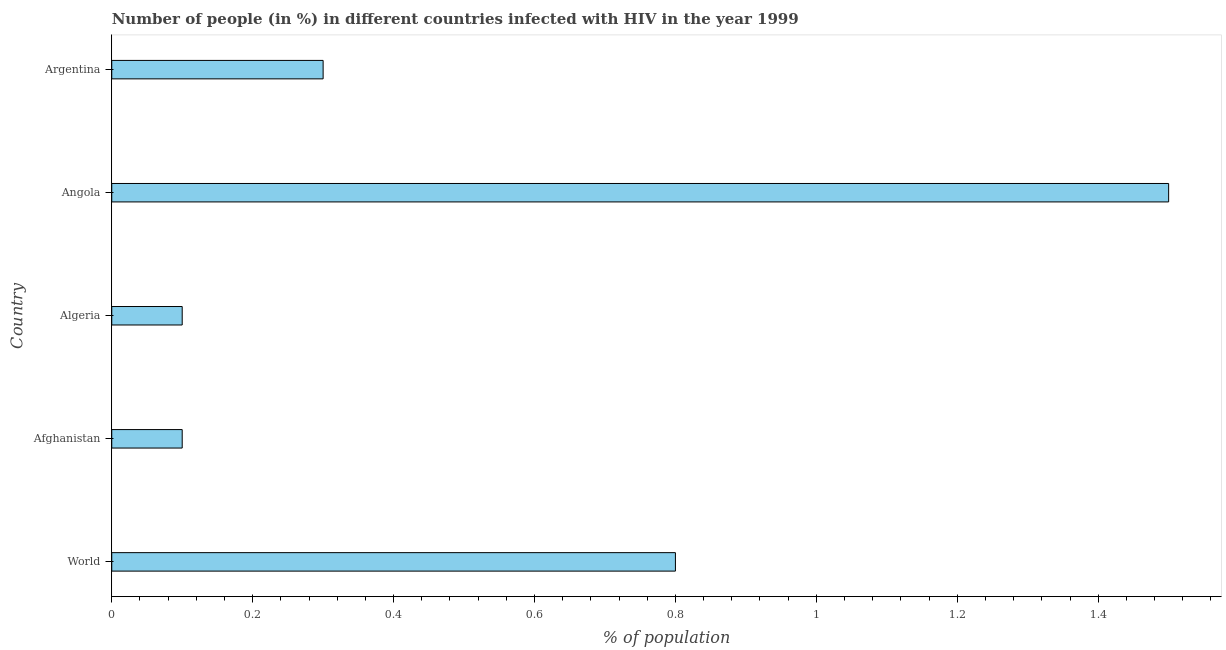Does the graph contain any zero values?
Your response must be concise. No. Does the graph contain grids?
Your response must be concise. No. What is the title of the graph?
Your answer should be compact. Number of people (in %) in different countries infected with HIV in the year 1999. What is the label or title of the X-axis?
Give a very brief answer. % of population. What is the number of people infected with hiv in Algeria?
Provide a short and direct response. 0.1. Across all countries, what is the maximum number of people infected with hiv?
Provide a succinct answer. 1.5. In which country was the number of people infected with hiv maximum?
Your response must be concise. Angola. In which country was the number of people infected with hiv minimum?
Give a very brief answer. Afghanistan. What is the difference between the number of people infected with hiv in Angola and World?
Keep it short and to the point. 0.7. What is the average number of people infected with hiv per country?
Your response must be concise. 0.56. What is the median number of people infected with hiv?
Your response must be concise. 0.3. What is the ratio of the number of people infected with hiv in Afghanistan to that in World?
Give a very brief answer. 0.12. Is the number of people infected with hiv in Afghanistan less than that in Angola?
Ensure brevity in your answer.  Yes. Is the sum of the number of people infected with hiv in Afghanistan and Angola greater than the maximum number of people infected with hiv across all countries?
Your answer should be compact. Yes. How many bars are there?
Offer a terse response. 5. What is the % of population of Afghanistan?
Provide a succinct answer. 0.1. What is the % of population in Algeria?
Ensure brevity in your answer.  0.1. What is the difference between the % of population in World and Afghanistan?
Make the answer very short. 0.7. What is the difference between the % of population in World and Algeria?
Give a very brief answer. 0.7. What is the difference between the % of population in World and Argentina?
Ensure brevity in your answer.  0.5. What is the difference between the % of population in Afghanistan and Algeria?
Offer a terse response. 0. What is the difference between the % of population in Algeria and Angola?
Keep it short and to the point. -1.4. What is the difference between the % of population in Angola and Argentina?
Ensure brevity in your answer.  1.2. What is the ratio of the % of population in World to that in Angola?
Your answer should be very brief. 0.53. What is the ratio of the % of population in World to that in Argentina?
Make the answer very short. 2.67. What is the ratio of the % of population in Afghanistan to that in Angola?
Make the answer very short. 0.07. What is the ratio of the % of population in Afghanistan to that in Argentina?
Your answer should be very brief. 0.33. What is the ratio of the % of population in Algeria to that in Angola?
Provide a short and direct response. 0.07. What is the ratio of the % of population in Algeria to that in Argentina?
Keep it short and to the point. 0.33. 